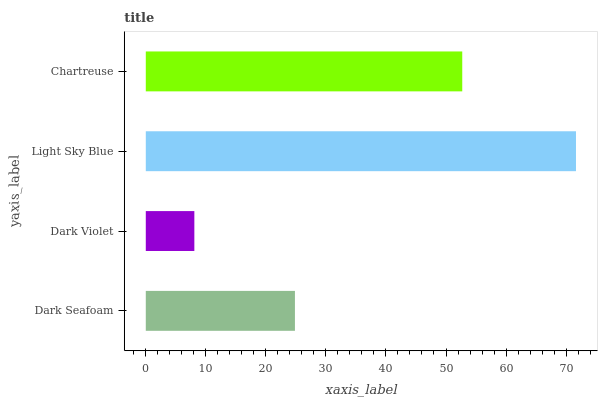Is Dark Violet the minimum?
Answer yes or no. Yes. Is Light Sky Blue the maximum?
Answer yes or no. Yes. Is Light Sky Blue the minimum?
Answer yes or no. No. Is Dark Violet the maximum?
Answer yes or no. No. Is Light Sky Blue greater than Dark Violet?
Answer yes or no. Yes. Is Dark Violet less than Light Sky Blue?
Answer yes or no. Yes. Is Dark Violet greater than Light Sky Blue?
Answer yes or no. No. Is Light Sky Blue less than Dark Violet?
Answer yes or no. No. Is Chartreuse the high median?
Answer yes or no. Yes. Is Dark Seafoam the low median?
Answer yes or no. Yes. Is Dark Violet the high median?
Answer yes or no. No. Is Chartreuse the low median?
Answer yes or no. No. 